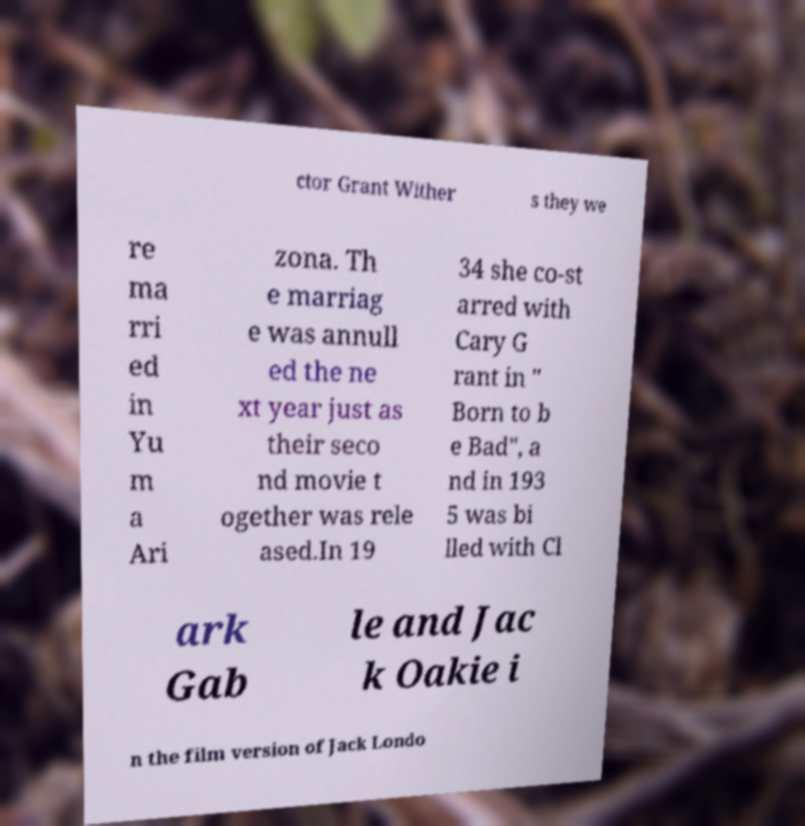I need the written content from this picture converted into text. Can you do that? ctor Grant Wither s they we re ma rri ed in Yu m a Ari zona. Th e marriag e was annull ed the ne xt year just as their seco nd movie t ogether was rele ased.In 19 34 she co-st arred with Cary G rant in " Born to b e Bad", a nd in 193 5 was bi lled with Cl ark Gab le and Jac k Oakie i n the film version of Jack Londo 